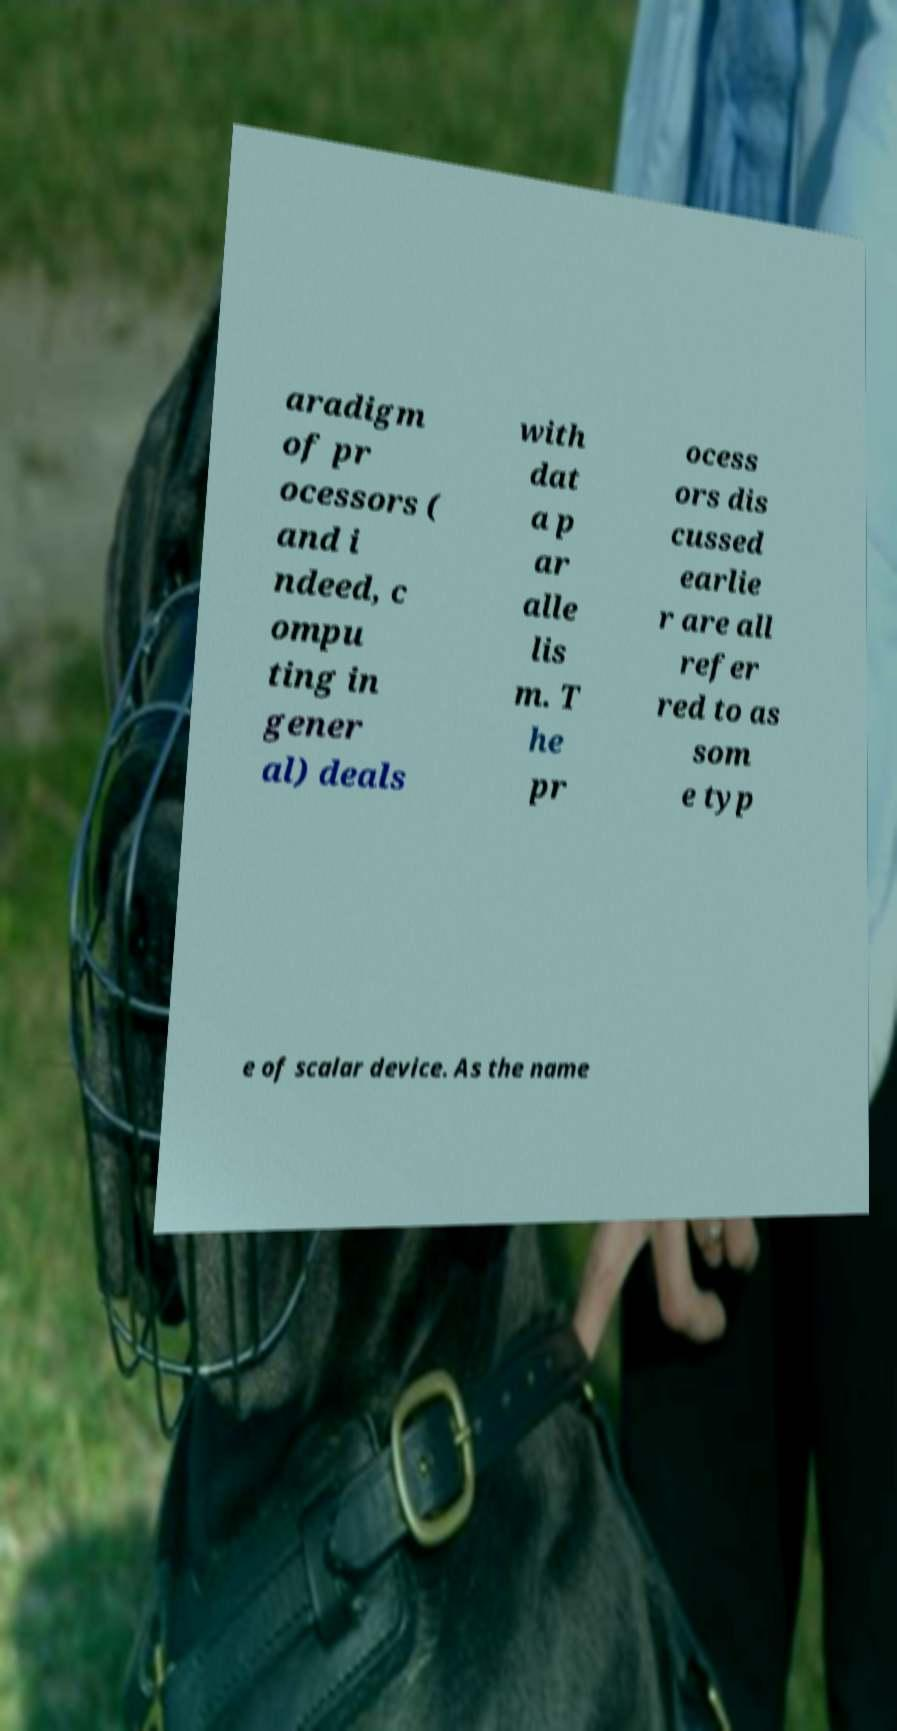I need the written content from this picture converted into text. Can you do that? aradigm of pr ocessors ( and i ndeed, c ompu ting in gener al) deals with dat a p ar alle lis m. T he pr ocess ors dis cussed earlie r are all refer red to as som e typ e of scalar device. As the name 